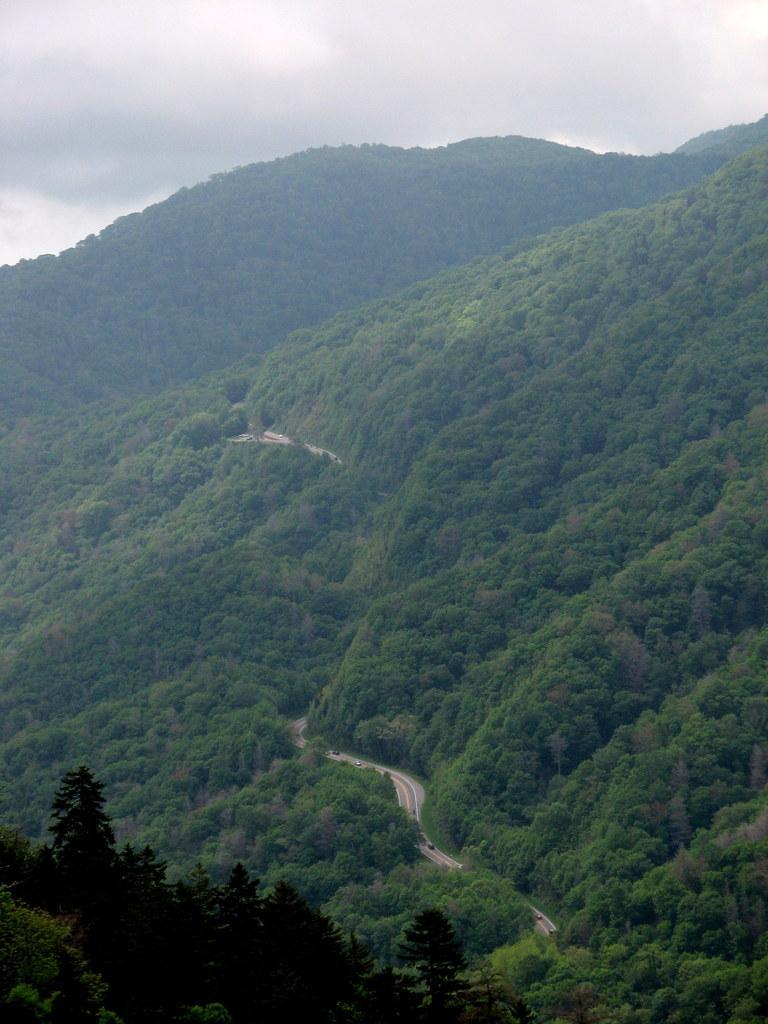Could you give a brief overview of what you see in this image? In this image I can see the road and few vehicles on the road. I can see few trees, few mountains and the sky. 